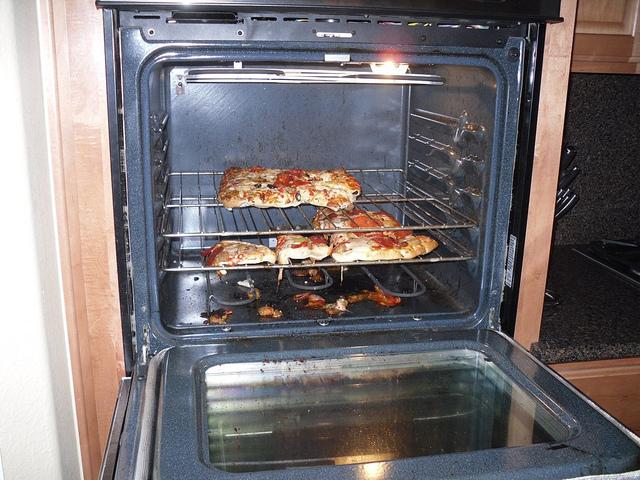Is there a pan in the image?
Concise answer only. No. Is the pizza done?
Answer briefly. Yes. Did the food make a mess?
Write a very short answer. Yes. 